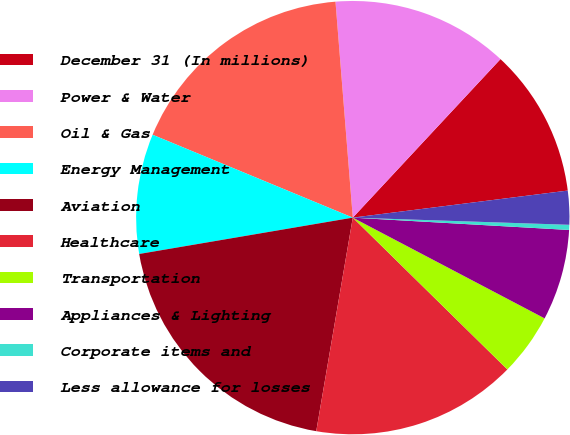Convert chart to OTSL. <chart><loc_0><loc_0><loc_500><loc_500><pie_chart><fcel>December 31 (In millions)<fcel>Power & Water<fcel>Oil & Gas<fcel>Energy Management<fcel>Aviation<fcel>Healthcare<fcel>Transportation<fcel>Appliances & Lighting<fcel>Corporate items and<fcel>Less allowance for losses<nl><fcel>11.07%<fcel>13.21%<fcel>17.48%<fcel>8.93%<fcel>19.62%<fcel>15.34%<fcel>4.66%<fcel>6.79%<fcel>0.38%<fcel>2.52%<nl></chart> 